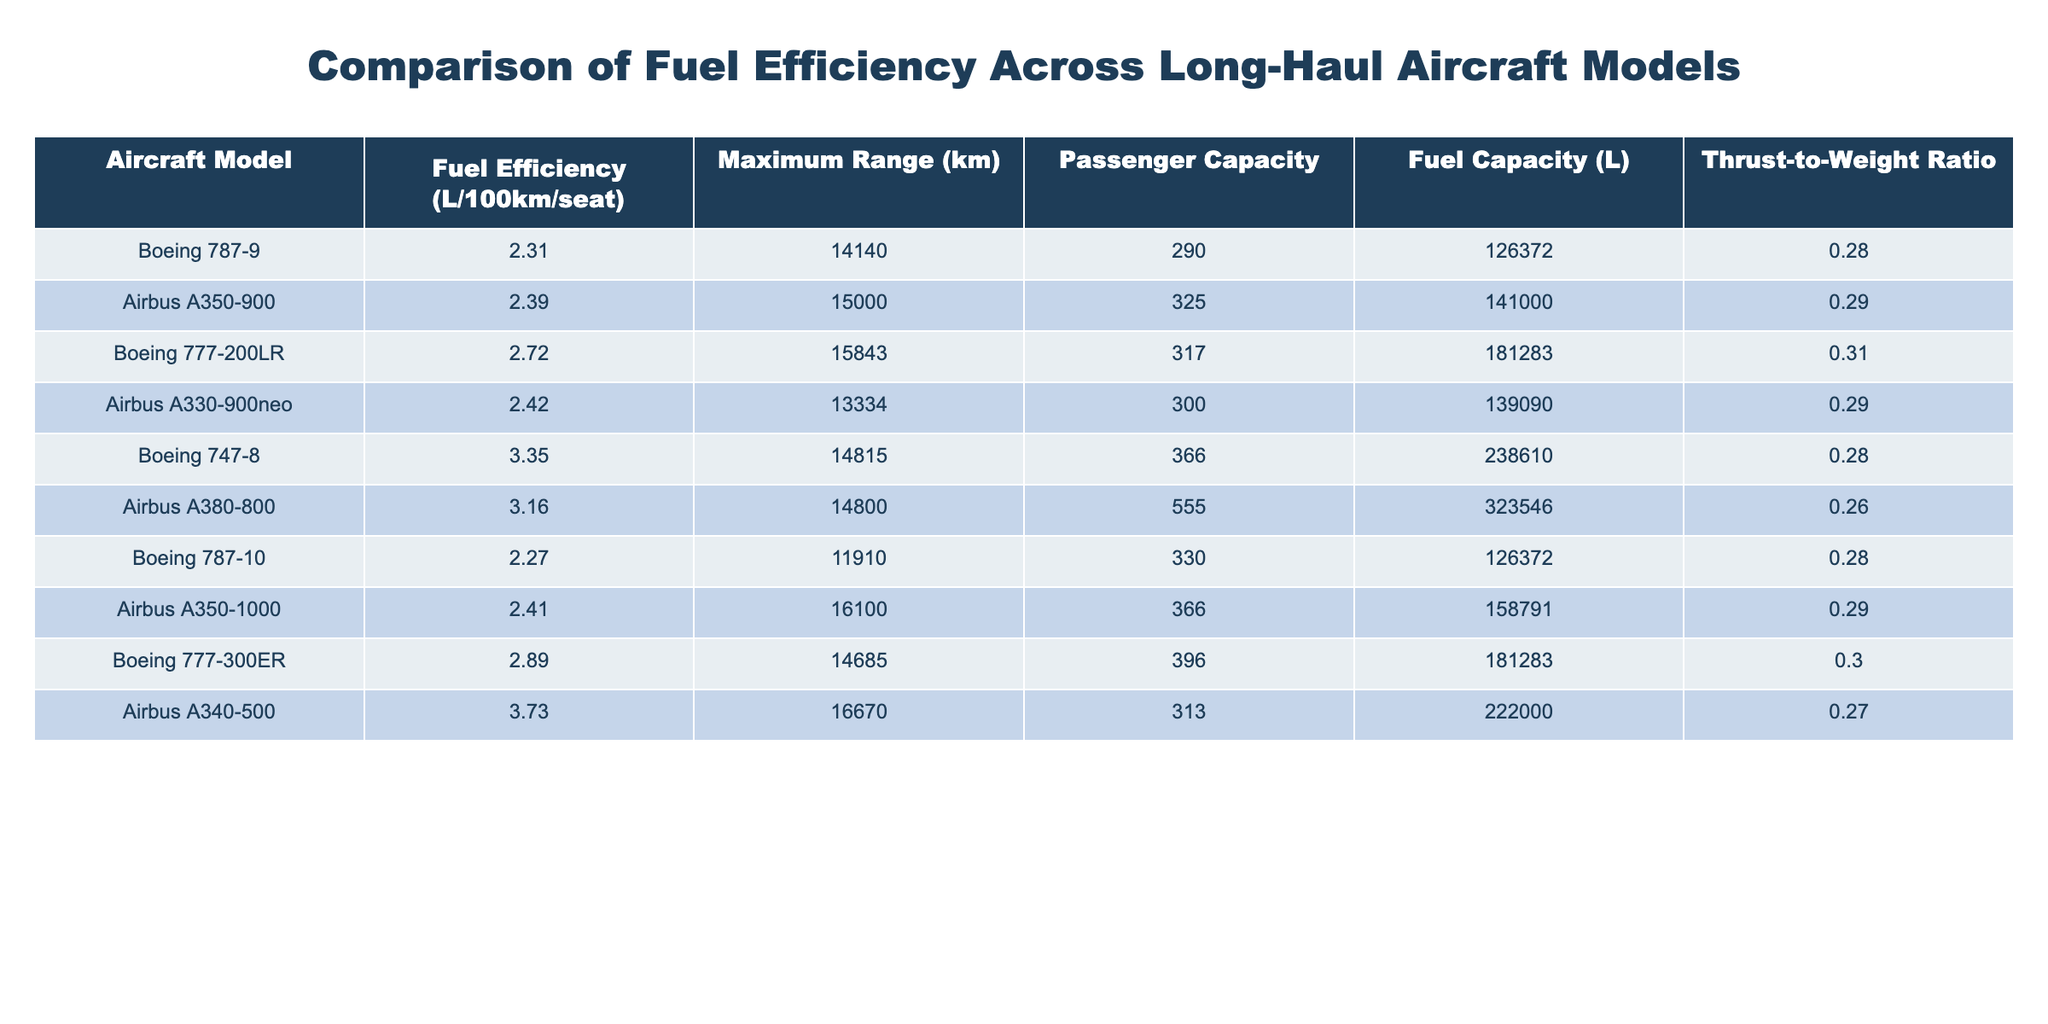What is the fuel efficiency of the Airbus A350-900? The fuel efficiency value is directly available in the table under the "Fuel Efficiency (L/100km/seat)" column for the Airbus A350-900. It shows the value as 2.39.
Answer: 2.39 Which aircraft has the highest passenger capacity? To find the highest passenger capacity, I look at the "Passenger Capacity" column. The Airbus A380-800 shows a capacity of 555, which is higher than all other listed aircraft.
Answer: 555 Calculate the difference in fuel efficiency between the Boeing 787-10 and the Boeing 747-8. First, I find the fuel efficiency values for both models: Boeing 787-10 is 2.27 and Boeing 747-8 is 3.35. I then calculate the difference: 3.35 - 2.27 = 1.08.
Answer: 1.08 Is the Thrust-to-Weight Ratio of the Boeing 777-300ER greater than 0.3? Looking at the "Thrust-to-Weight Ratio" column for the Boeing 777-300ER, the value is 0.302. Since 0.302 is not greater than 0.3, the answer is no.
Answer: No What is the average fuel efficiency of all the aircraft listed? To calculate the average fuel efficiency, I sum the fuel efficiency values: (2.31 + 2.39 + 2.72 + 2.42 + 3.35 + 3.16 + 2.27 + 2.41 + 2.89 + 3.73) = 28.25, and then divide by the number of aircraft (10): 28.25 / 10 = 2.825.
Answer: 2.83 Which aircraft is most efficient and has a maximum range exceeding 14,000 km? I check the table for fuel efficiency and maximum range. The Boeing 787-10 is the most fuel-efficient with a fuel efficiency of 2.27 and a maximum range of 11,910 km, which is less than 14,000 km. However, the Airbus A350-900 is 2.39 with a maximum range of 15,000 km, fitting the criteria.
Answer: Airbus A350-900 How many aircraft have a fuel efficiency greater than 3.0 L/100km/seat? In the fuel efficiency column, I can see that the Boeing 747-8 (3.35), Airbus A380-800 (3.16), and Airbus A340-500 (3.73) all exceed 3.0. So there are three such aircraft.
Answer: 3 Is the maximum range of the Boeing 777-200LR longer than that of the Airbus A330-900neo? The maximum range for Boeing 777-200LR is 15,843 km and for Airbus A330-900neo it is 13,334 km. Since 15,843 km is greater than 13,334 km, the answer is yes.
Answer: Yes 